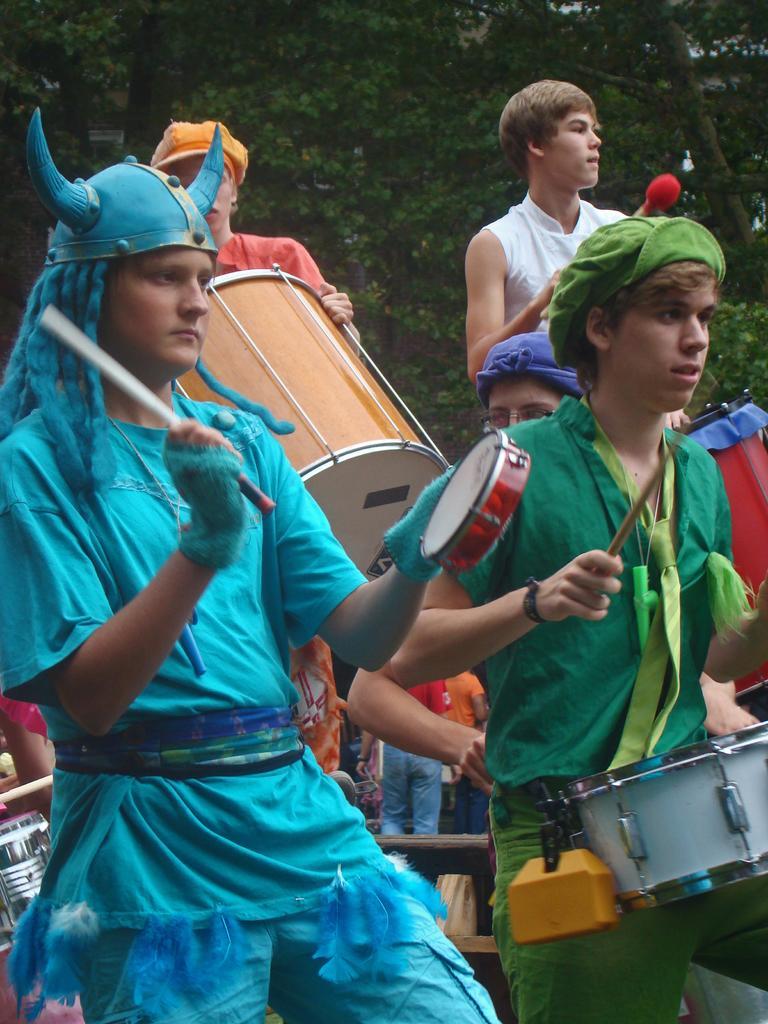How would you summarize this image in a sentence or two? Here we can see that a group of people are standing and playing drums, and here are the trees. 